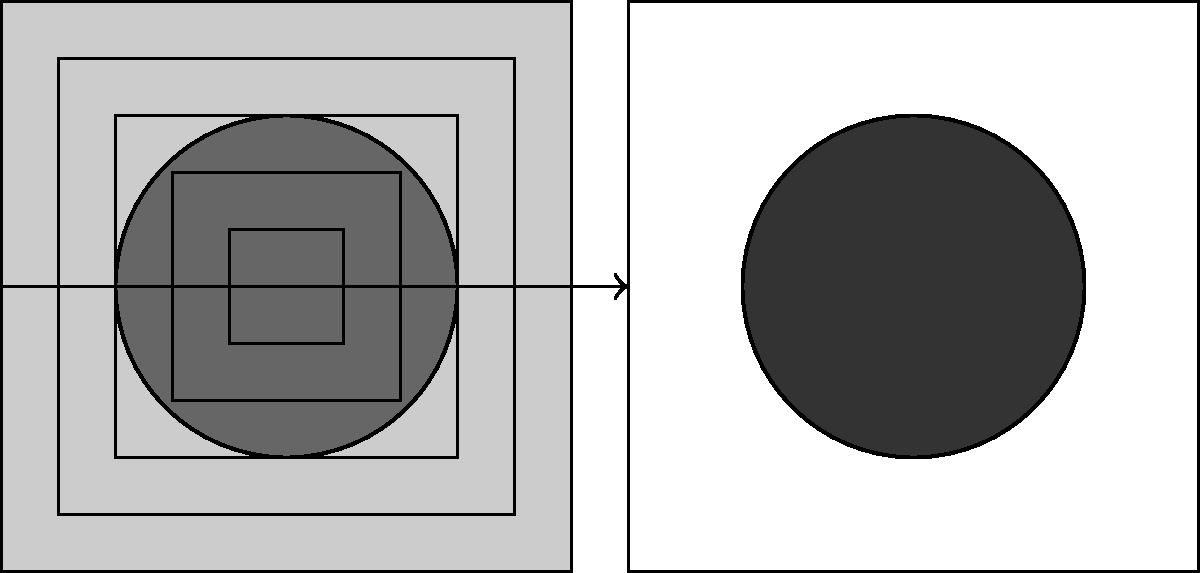In the context of image segmentation using U-Net architecture, what is the primary purpose of the contracting path (left side) of the network, and how does it contribute to the overall segmentation process? To understand the role of the contracting path in U-Net architecture for image segmentation, let's break it down step-by-step:

1. U-Net Architecture: The U-Net is a convolutional neural network designed for image segmentation tasks, particularly in medical imaging. It has a characteristic U-shape, consisting of a contracting path (left side) and an expansive path (right side).

2. Contracting Path Structure:
   a. The contracting path consists of repeated application of:
      - Convolutional layers
      - ReLU activation functions
      - Max pooling operations
   b. It typically has 4-5 levels, each level doubling the number of feature channels.

3. Feature Extraction:
   a. The primary purpose of the contracting path is to capture and extract features from the input image.
   b. As we go deeper into the network, it learns to recognize more complex and abstract features.

4. Spatial Information Reduction:
   a. The max pooling operations reduce the spatial dimensions of the feature maps.
   b. This allows the network to increase its receptive field and capture context from a larger area of the input image.

5. Increase in Feature Channels:
   a. While spatial dimensions decrease, the number of feature channels increases.
   b. This allows the network to learn a rich set of features at different scales.

6. Context Capturing:
   a. The deepest layers of the contracting path capture global context from the entire image.
   b. This global context is crucial for accurate segmentation, especially in complex medical images.

7. Connection to Expansive Path:
   a. The features learned in the contracting path are passed to the corresponding layers in the expansive path through skip connections.
   b. These skip connections help in preserving fine-grained details for precise segmentation.

In summary, the contracting path of the U-Net architecture is essential for extracting and learning hierarchical features from the input image, capturing both local and global context, which is then used by the expansive path to produce the final segmentation output.
Answer: Feature extraction and context capturing 